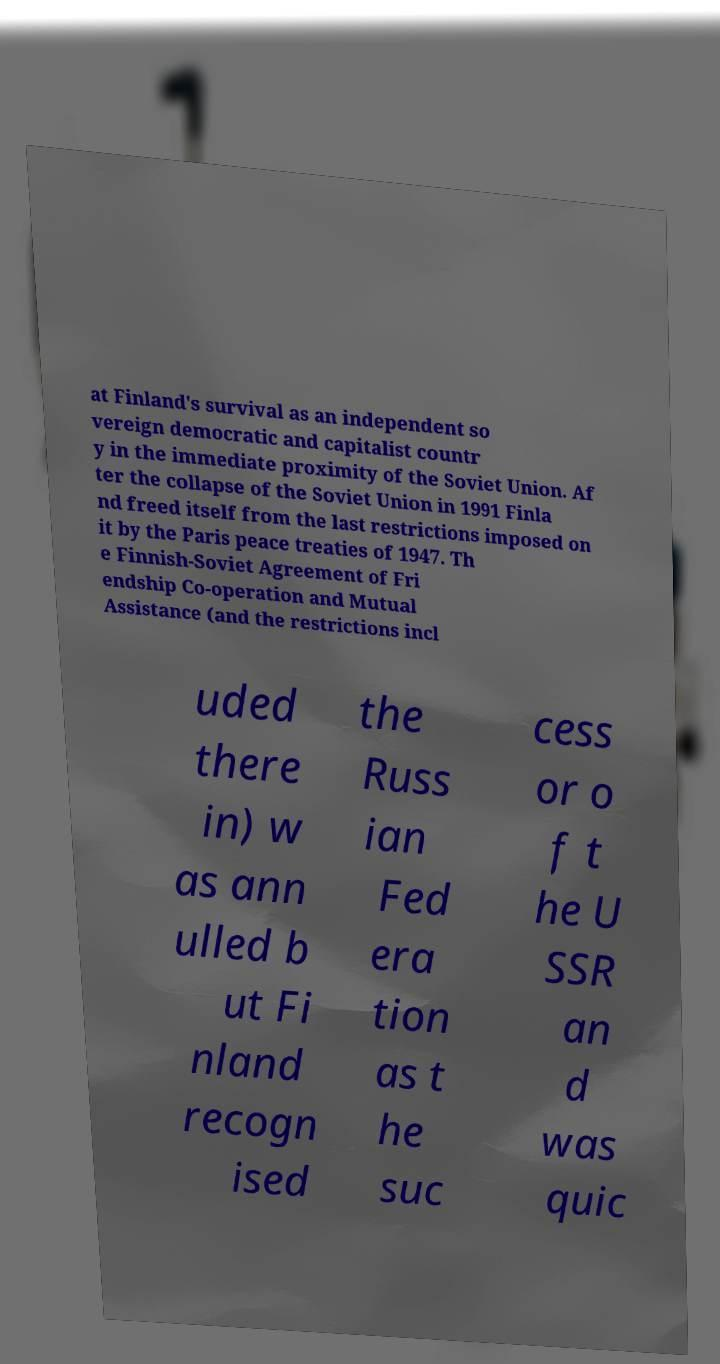For documentation purposes, I need the text within this image transcribed. Could you provide that? at Finland's survival as an independent so vereign democratic and capitalist countr y in the immediate proximity of the Soviet Union. Af ter the collapse of the Soviet Union in 1991 Finla nd freed itself from the last restrictions imposed on it by the Paris peace treaties of 1947. Th e Finnish-Soviet Agreement of Fri endship Co-operation and Mutual Assistance (and the restrictions incl uded there in) w as ann ulled b ut Fi nland recogn ised the Russ ian Fed era tion as t he suc cess or o f t he U SSR an d was quic 